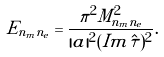Convert formula to latex. <formula><loc_0><loc_0><loc_500><loc_500>E _ { n _ { m } n _ { e } } = \frac { \pi ^ { 2 } M _ { n _ { m } n _ { e } } ^ { 2 } } { | a | ^ { 2 } ( I m \hat { \tau } ) ^ { 2 } } .</formula> 